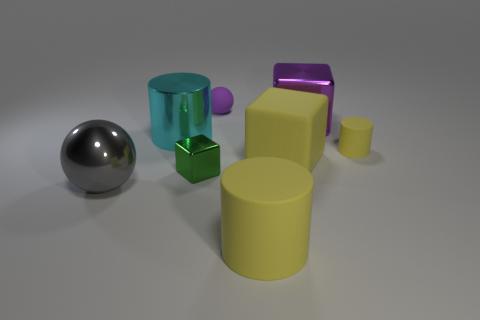Are any large metal blocks visible?
Keep it short and to the point. Yes. How many things are yellow matte things that are left of the tiny yellow matte cylinder or small yellow rubber things?
Keep it short and to the point. 3. There is a metallic ball; does it have the same color as the rubber cylinder that is behind the small block?
Your answer should be very brief. No. Are there any green blocks that have the same size as the gray metal ball?
Offer a terse response. No. There is a large thing that is to the left of the big cylinder that is on the left side of the big yellow matte cylinder; what is it made of?
Your answer should be compact. Metal. What number of metallic cylinders are the same color as the tiny block?
Keep it short and to the point. 0. There is a green object that is made of the same material as the purple cube; what is its shape?
Offer a terse response. Cube. There is a shiny block that is left of the small ball; how big is it?
Your response must be concise. Small. Is the number of matte objects that are in front of the tiny yellow rubber cylinder the same as the number of yellow matte things that are behind the large gray metal object?
Give a very brief answer. Yes. There is a rubber cylinder that is behind the large gray thing that is left of the yellow cylinder that is in front of the small yellow cylinder; what color is it?
Your answer should be very brief. Yellow. 